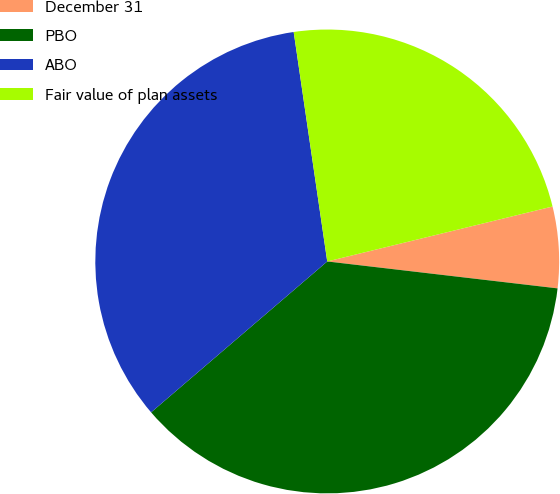Convert chart. <chart><loc_0><loc_0><loc_500><loc_500><pie_chart><fcel>December 31<fcel>PBO<fcel>ABO<fcel>Fair value of plan assets<nl><fcel>5.66%<fcel>36.87%<fcel>33.96%<fcel>23.5%<nl></chart> 